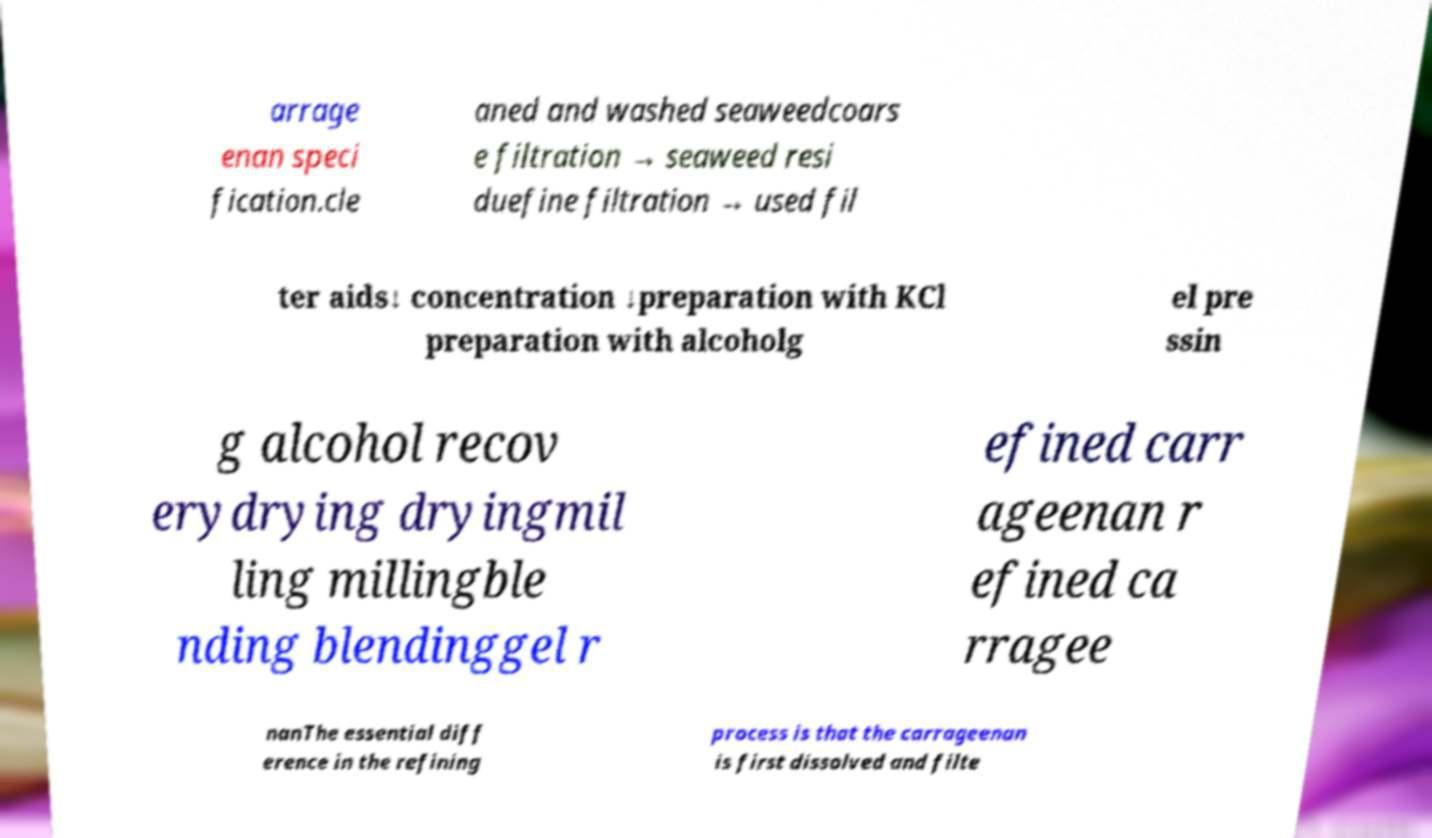What messages or text are displayed in this image? I need them in a readable, typed format. arrage enan speci fication.cle aned and washed seaweedcoars e filtration → seaweed resi duefine filtration → used fil ter aids↓ concentration ↓preparation with KCl preparation with alcoholg el pre ssin g alcohol recov erydrying dryingmil ling millingble nding blendinggel r efined carr ageenan r efined ca rragee nanThe essential diff erence in the refining process is that the carrageenan is first dissolved and filte 